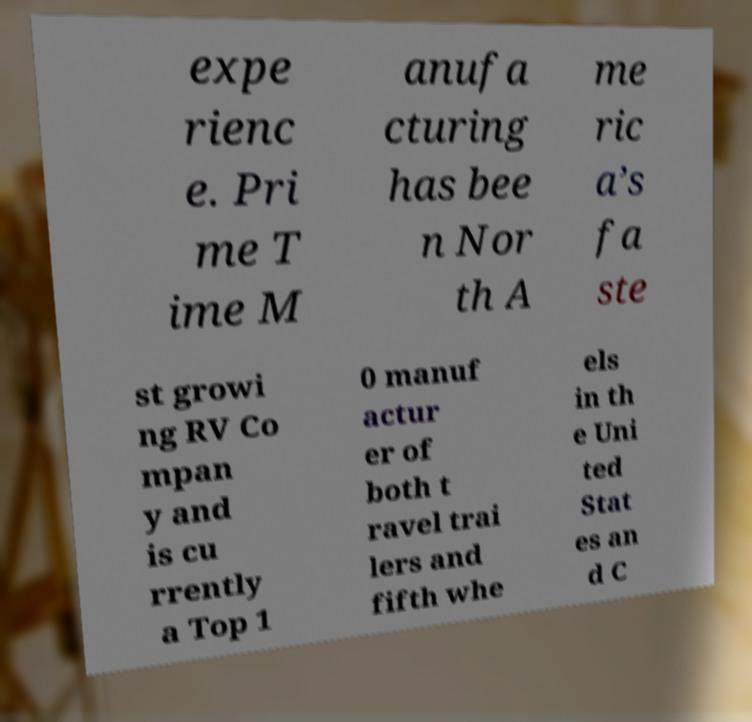Please identify and transcribe the text found in this image. expe rienc e. Pri me T ime M anufa cturing has bee n Nor th A me ric a’s fa ste st growi ng RV Co mpan y and is cu rrently a Top 1 0 manuf actur er of both t ravel trai lers and fifth whe els in th e Uni ted Stat es an d C 